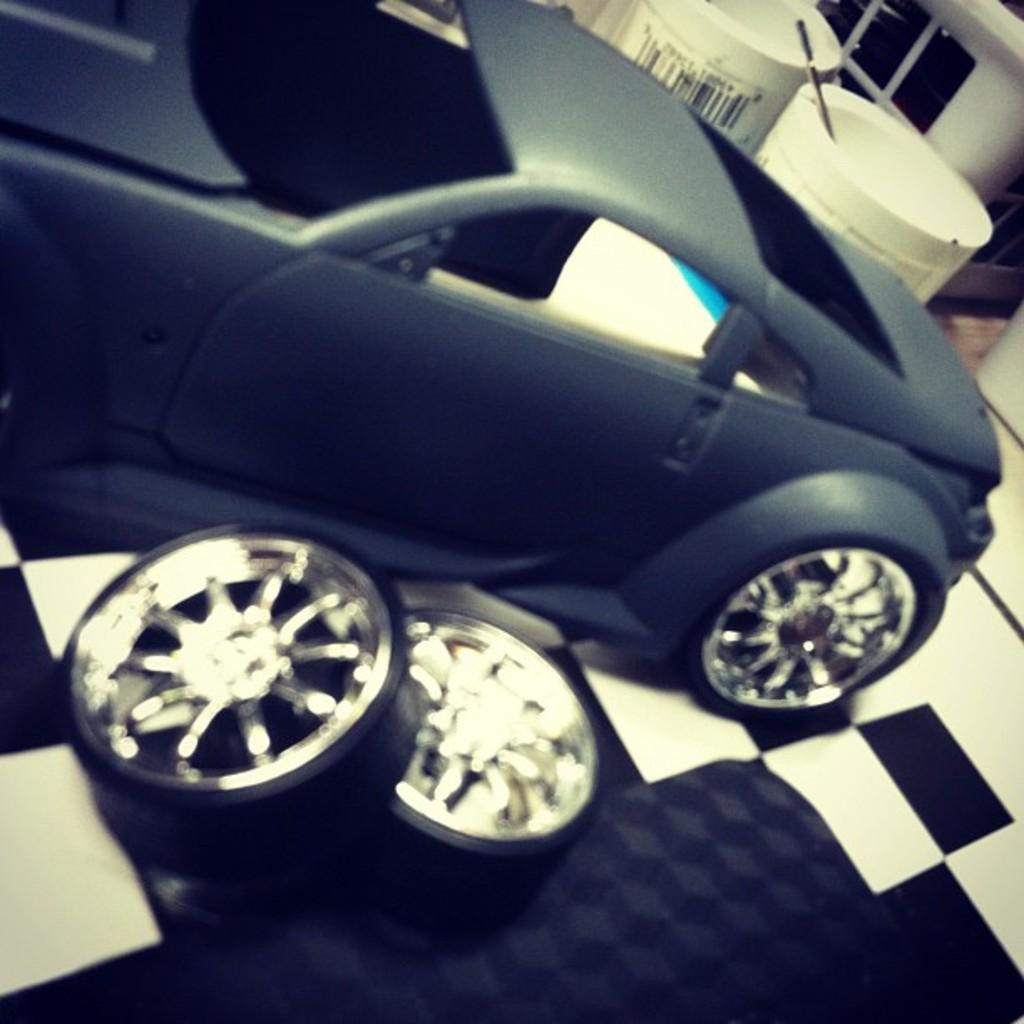What type of toy is present in the image? There is a toy car in the image. What part of the toy car can be seen in the image? There are toy wheels in the image. Where are the toy wheels located? The toy wheels are on an object. What can be seen in the background of the image? There are objects visible in the background of the image. What type of veil is draped over the toy car in the image? There is no veil present in the image; it features a toy car with toy wheels. 